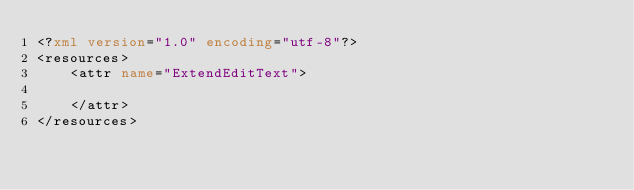Convert code to text. <code><loc_0><loc_0><loc_500><loc_500><_XML_><?xml version="1.0" encoding="utf-8"?>
<resources>
    <attr name="ExtendEditText">

    </attr>
</resources></code> 